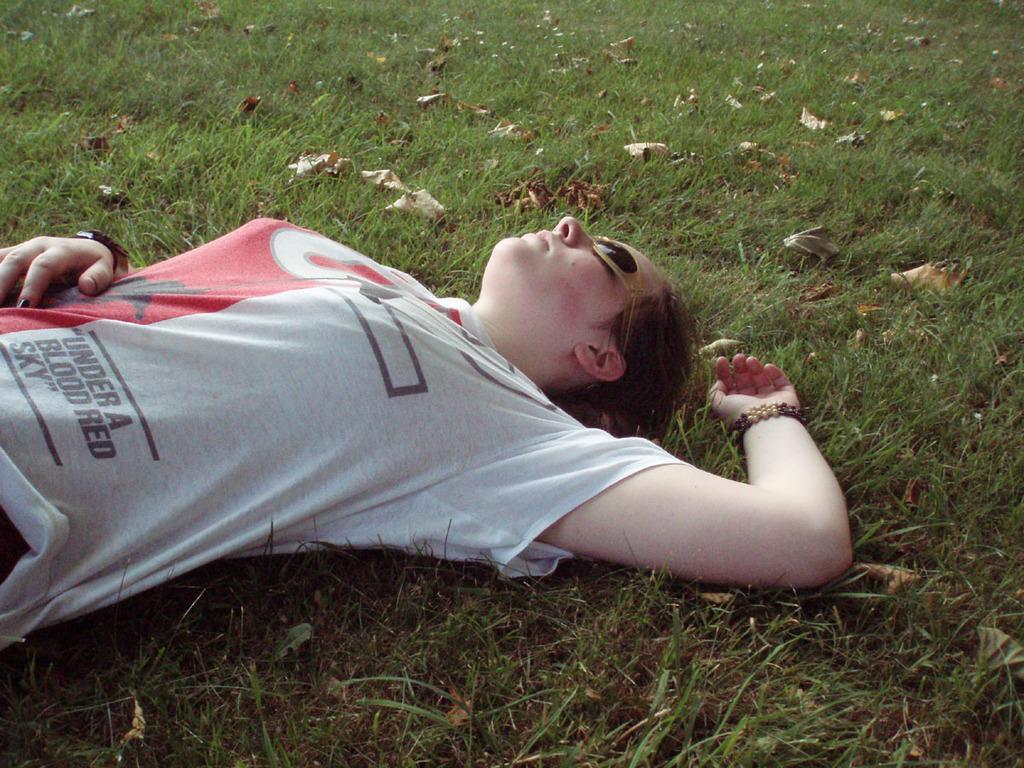In one or two sentences, can you explain what this image depicts? In this picture I can see woman is lying on the grass, side there are some dry leaves on the grass. 